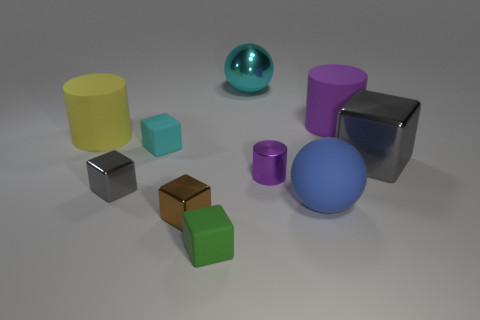Subtract 2 cubes. How many cubes are left? 3 Subtract all cyan cubes. How many cubes are left? 4 Subtract all small gray shiny blocks. How many blocks are left? 4 Subtract all red cubes. Subtract all green cylinders. How many cubes are left? 5 Subtract all spheres. How many objects are left? 8 Add 3 large blue rubber spheres. How many large blue rubber spheres are left? 4 Add 1 tiny red matte cylinders. How many tiny red matte cylinders exist? 1 Subtract 0 yellow blocks. How many objects are left? 10 Subtract all gray shiny cubes. Subtract all brown metal blocks. How many objects are left? 7 